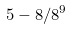Convert formula to latex. <formula><loc_0><loc_0><loc_500><loc_500>5 - 8 / 8 ^ { 9 }</formula> 